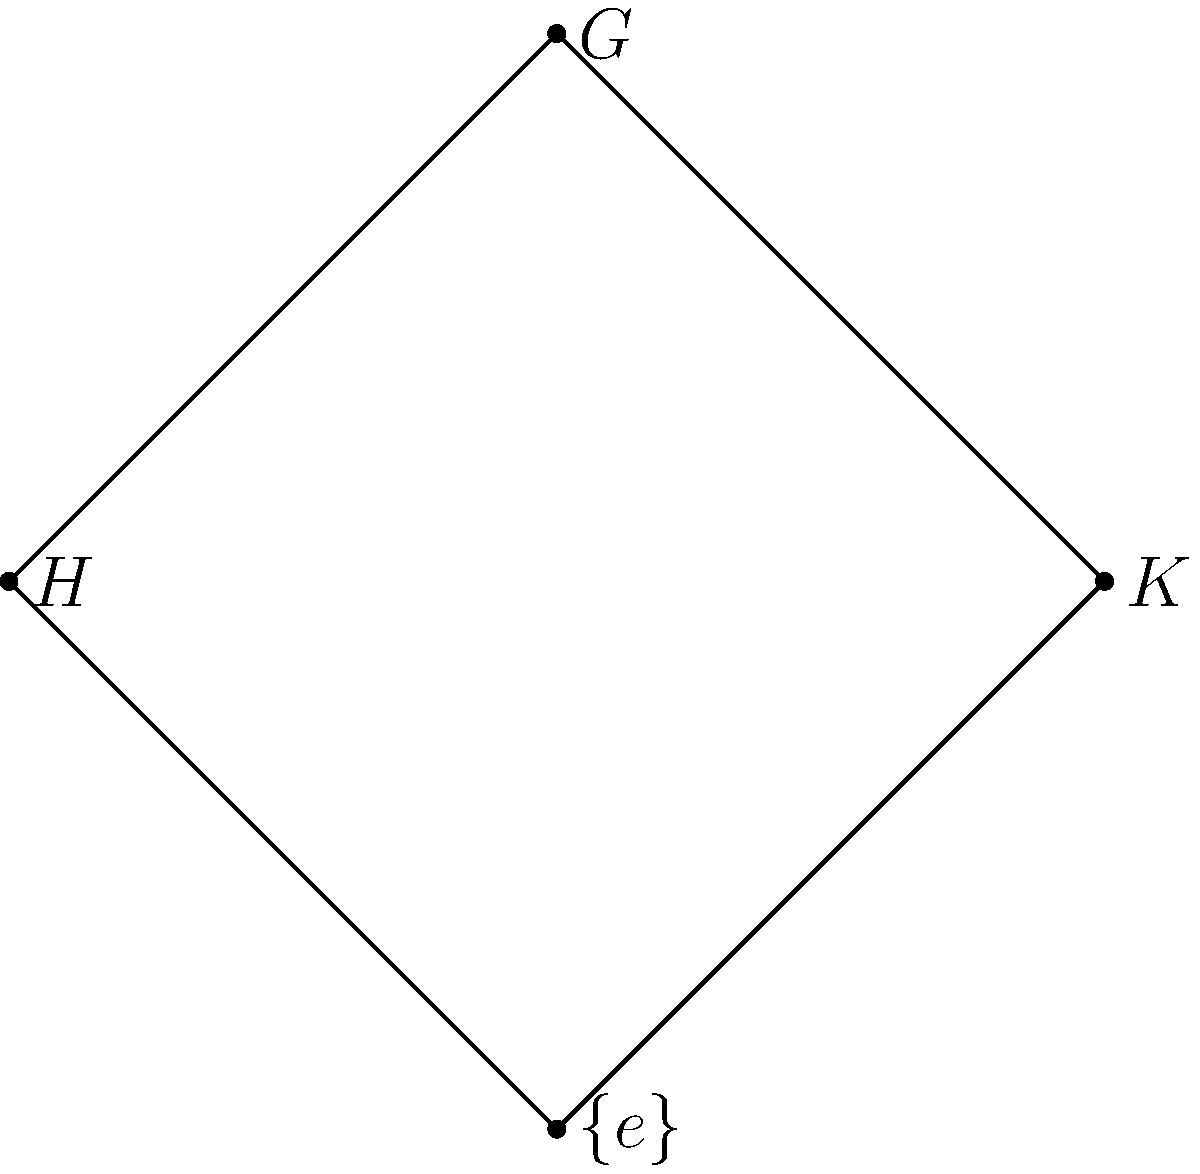As a research assistant studying cutting-edge database technologies, you encounter a group theory concept related to database indexing structures. Given the subgroup lattice diagram above for a group $G$ with subgroups $H$ and $K$, what is the order of group $G$ if $|H| = 6$ and $|K| = 10$? Let's approach this step-by-step:

1) In a subgroup lattice, the bottom element represents the trivial subgroup $\{e\}$, and the top element represents the entire group $G$.

2) The lines in the diagram represent subset relationships. Here, both $H$ and $K$ are subgroups of $G$, and both contain the trivial subgroup $\{e\}$.

3) The key theorem we need here is Lagrange's Theorem, which states that the order of a subgroup must divide the order of the group.

4) Given $|H| = 6$ and $|K| = 10$, we need to find the least common multiple (LCM) of 6 and 10.

5) To find the LCM, first factorize:
   6 = 2 * 3
   10 = 2 * 5

6) The LCM is the product of each prime factor taken to the highest power in which it occurs:
   LCM(6,10) = 2 * 3 * 5 = 30

7) Therefore, the smallest possible order for $G$ that satisfies the conditions is 30.

This concept of finding the least common multiple is analogous to finding the optimal block size in database indexing structures to accommodate different record sizes efficiently.
Answer: 30 